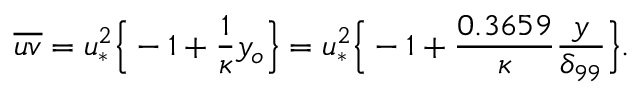<formula> <loc_0><loc_0><loc_500><loc_500>\overline { u v } = u _ { * } ^ { 2 } \left \{ - 1 + \frac { 1 } { \kappa } y _ { o } \right \} = u _ { * } ^ { 2 } \left \{ - 1 + \frac { 0 . 3 6 5 9 } { \kappa } \frac { y } { \delta _ { 9 9 } } \right \} .</formula> 